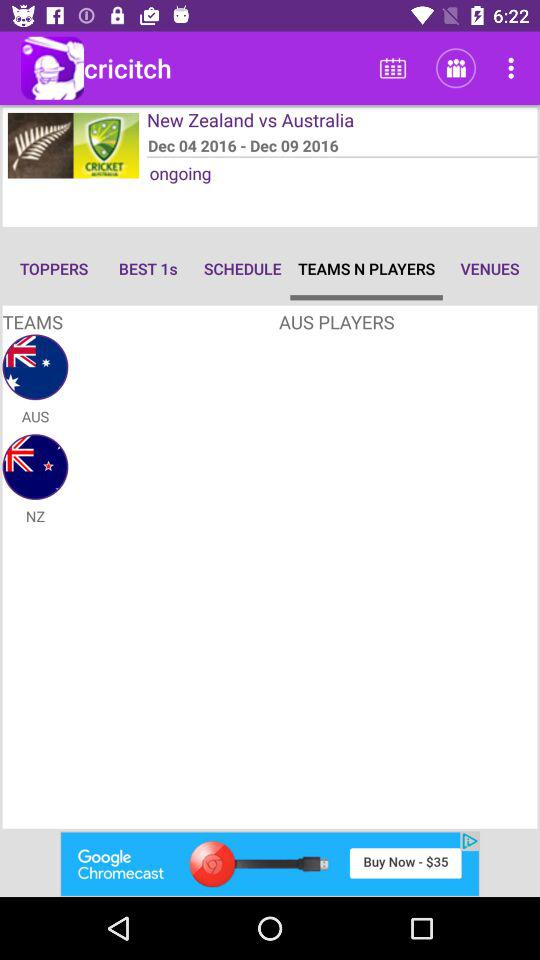What's the date of the match between New Zealand and Australia? The date of the match between New Zealand and Australia is from December 4, 2016 to December 9, 2016. 